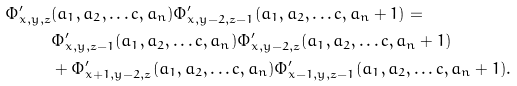<formula> <loc_0><loc_0><loc_500><loc_500>\Phi ^ { \prime } _ { x , y , z } & ( a _ { 1 } , a _ { 2 } , \dots c , a _ { n } ) \Phi ^ { \prime } _ { x , y - 2 , z - 1 } ( a _ { 1 } , a _ { 2 } , \dots c , a _ { n } + 1 ) = \\ & \Phi ^ { \prime } _ { x , y , z - 1 } ( a _ { 1 } , a _ { 2 } , \dots c , a _ { n } ) \Phi ^ { \prime } _ { x , y - 2 , z } ( a _ { 1 } , a _ { 2 } , \dots c , a _ { n } + 1 ) \\ & + \Phi ^ { \prime } _ { x + 1 , y - 2 , z } ( a _ { 1 } , a _ { 2 } , \dots c , a _ { n } ) \Phi ^ { \prime } _ { x - 1 , y , z - 1 } ( a _ { 1 } , a _ { 2 } , \dots c , a _ { n } + 1 ) .</formula> 